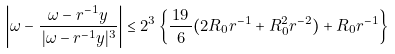Convert formula to latex. <formula><loc_0><loc_0><loc_500><loc_500>\left | \omega - \frac { \omega - r ^ { - 1 } y } { \, | \omega - r ^ { - 1 } y | ^ { 3 } } \right | \leq 2 ^ { 3 } \left \{ \frac { \, 1 9 \, } { 6 } ( 2 R _ { 0 } r ^ { - 1 } + R _ { 0 } ^ { 2 } r ^ { - 2 } ) + R _ { 0 } r ^ { - 1 } \right \}</formula> 